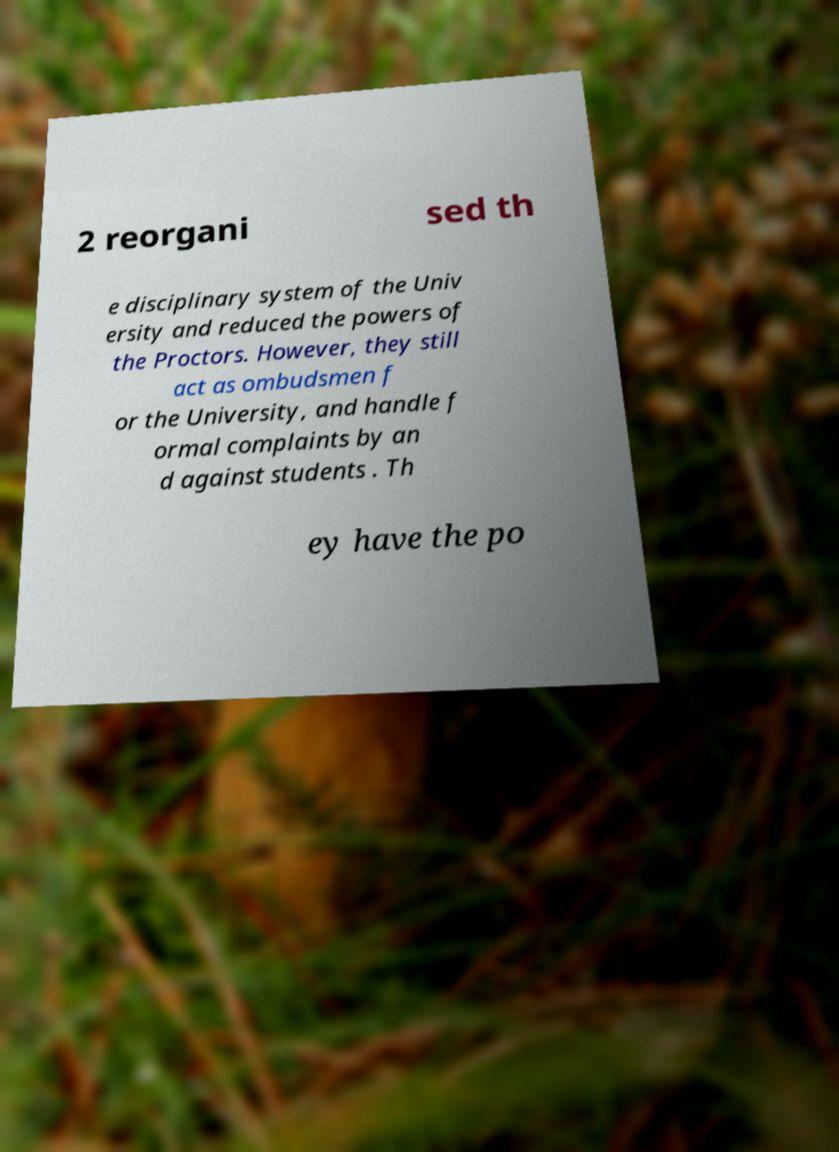Can you read and provide the text displayed in the image?This photo seems to have some interesting text. Can you extract and type it out for me? 2 reorgani sed th e disciplinary system of the Univ ersity and reduced the powers of the Proctors. However, they still act as ombudsmen f or the University, and handle f ormal complaints by an d against students . Th ey have the po 